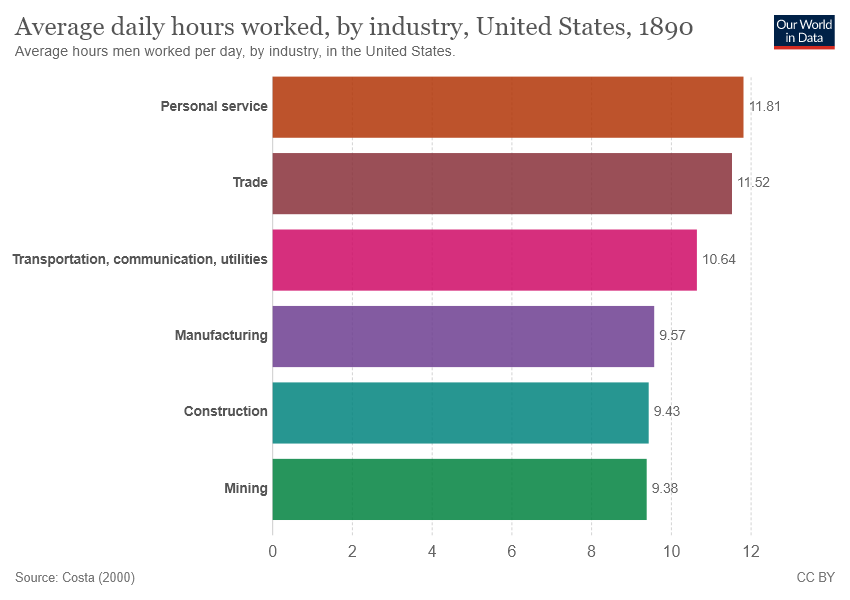Specify some key components in this picture. The average of the largest two values is approximately 11.665. There are 6 color bars in the chart. 